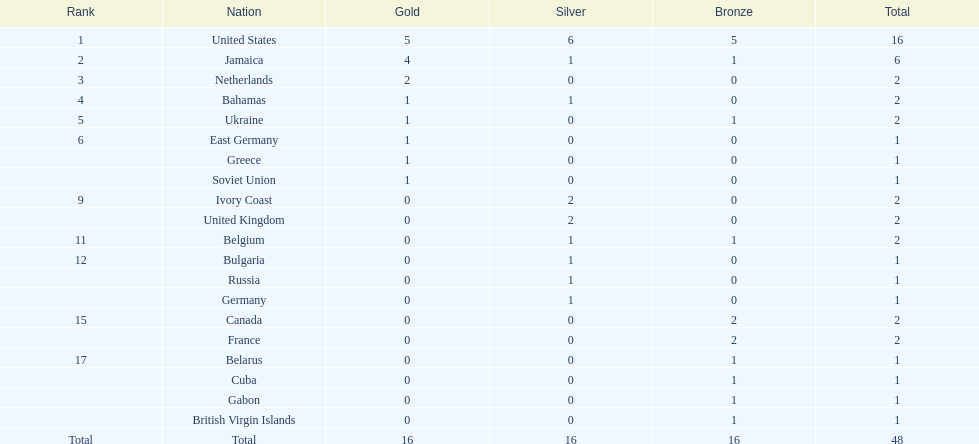What country won the most silver medals? United States. 